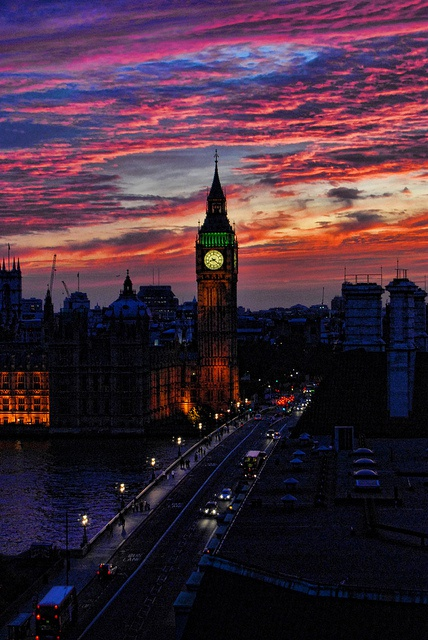Describe the objects in this image and their specific colors. I can see bus in navy, black, darkblue, and maroon tones, clock in navy, olive, and khaki tones, car in navy, black, gray, and brown tones, car in navy, black, gray, and white tones, and car in black, navy, and purple tones in this image. 